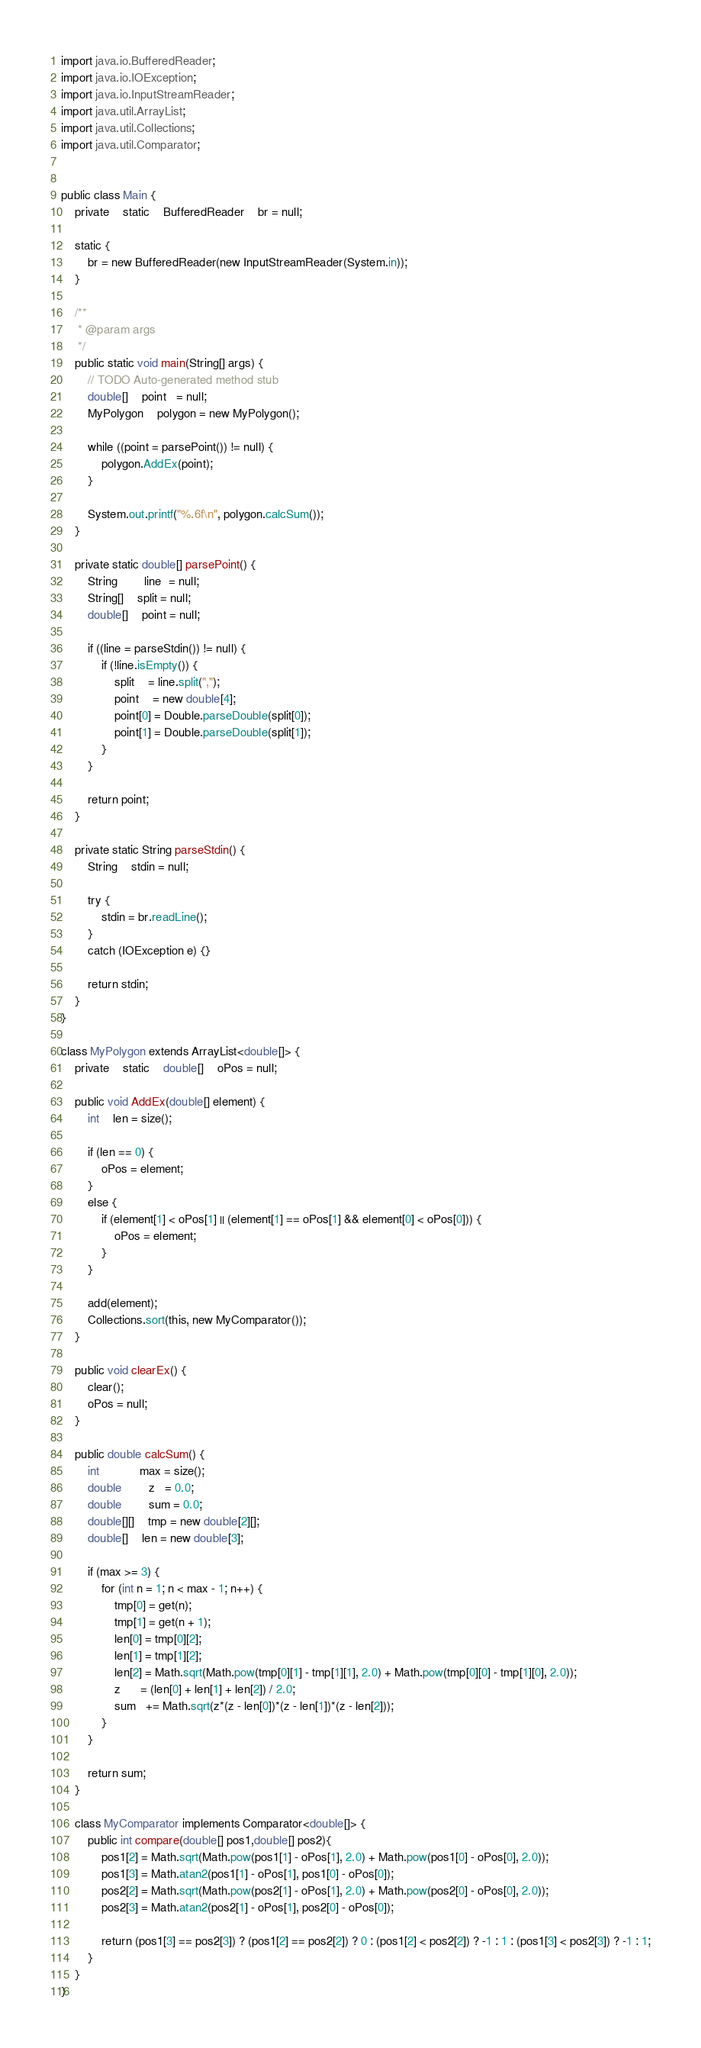<code> <loc_0><loc_0><loc_500><loc_500><_Java_>import java.io.BufferedReader;
import java.io.IOException;
import java.io.InputStreamReader;
import java.util.ArrayList;
import java.util.Collections;
import java.util.Comparator;


public class Main {
	private	static	BufferedReader	br = null;

	static {
		br = new BufferedReader(new InputStreamReader(System.in));
	}

	/**
	 * @param args
	 */
	public static void main(String[] args) {
		// TODO Auto-generated method stub
		double[]	point   = null;
		MyPolygon	polygon = new MyPolygon();

		while ((point = parsePoint()) != null) {
			polygon.AddEx(point);
		}

		System.out.printf("%.6f\n", polygon.calcSum());
	}

	private static double[] parsePoint() {
		String		line  = null;
		String[]	split = null;
		double[]	point = null;

		if ((line = parseStdin()) != null) {
			if (!line.isEmpty()) {
				split    = line.split(",");
				point    = new double[4];
				point[0] = Double.parseDouble(split[0]);
				point[1] = Double.parseDouble(split[1]);
			}
		}

		return point;
	}

	private static String parseStdin() {
		String	stdin = null;

		try {
			stdin = br.readLine();
		}
		catch (IOException e) {}

		return stdin;
	}
}

class MyPolygon extends ArrayList<double[]> {
	private	static	double[]	oPos = null;

	public void AddEx(double[] element) {
		int	len = size();

		if (len == 0) {
			oPos = element;
		}
		else {
			if (element[1] < oPos[1] || (element[1] == oPos[1] && element[0] < oPos[0])) {
				oPos = element;
			}
		}

		add(element);
		Collections.sort(this, new MyComparator());
	}

	public void clearEx() {
		clear();
		oPos = null;
	}

	public double calcSum() {
		int			max = size();
		double		z   = 0.0;
		double		sum = 0.0;
		double[][]	tmp = new double[2][];
		double[]	len = new double[3];

		if (max >= 3) {
			for (int n = 1; n < max - 1; n++) {
				tmp[0] = get(n);
				tmp[1] = get(n + 1);
				len[0] = tmp[0][2];
				len[1] = tmp[1][2];
				len[2] = Math.sqrt(Math.pow(tmp[0][1] - tmp[1][1], 2.0) + Math.pow(tmp[0][0] - tmp[1][0], 2.0));
				z      = (len[0] + len[1] + len[2]) / 2.0;
				sum   += Math.sqrt(z*(z - len[0])*(z - len[1])*(z - len[2]));
			}
		}

		return sum;
	}

	class MyComparator implements Comparator<double[]> {
		public int compare(double[] pos1,double[] pos2){
			pos1[2] = Math.sqrt(Math.pow(pos1[1] - oPos[1], 2.0) + Math.pow(pos1[0] - oPos[0], 2.0));
			pos1[3] = Math.atan2(pos1[1] - oPos[1], pos1[0] - oPos[0]);
			pos2[2] = Math.sqrt(Math.pow(pos2[1] - oPos[1], 2.0) + Math.pow(pos2[0] - oPos[0], 2.0));
			pos2[3] = Math.atan2(pos2[1] - oPos[1], pos2[0] - oPos[0]);

			return (pos1[3] == pos2[3]) ? (pos1[2] == pos2[2]) ? 0 : (pos1[2] < pos2[2]) ? -1 : 1 : (pos1[3] < pos2[3]) ? -1 : 1;
		}
	}
}</code> 